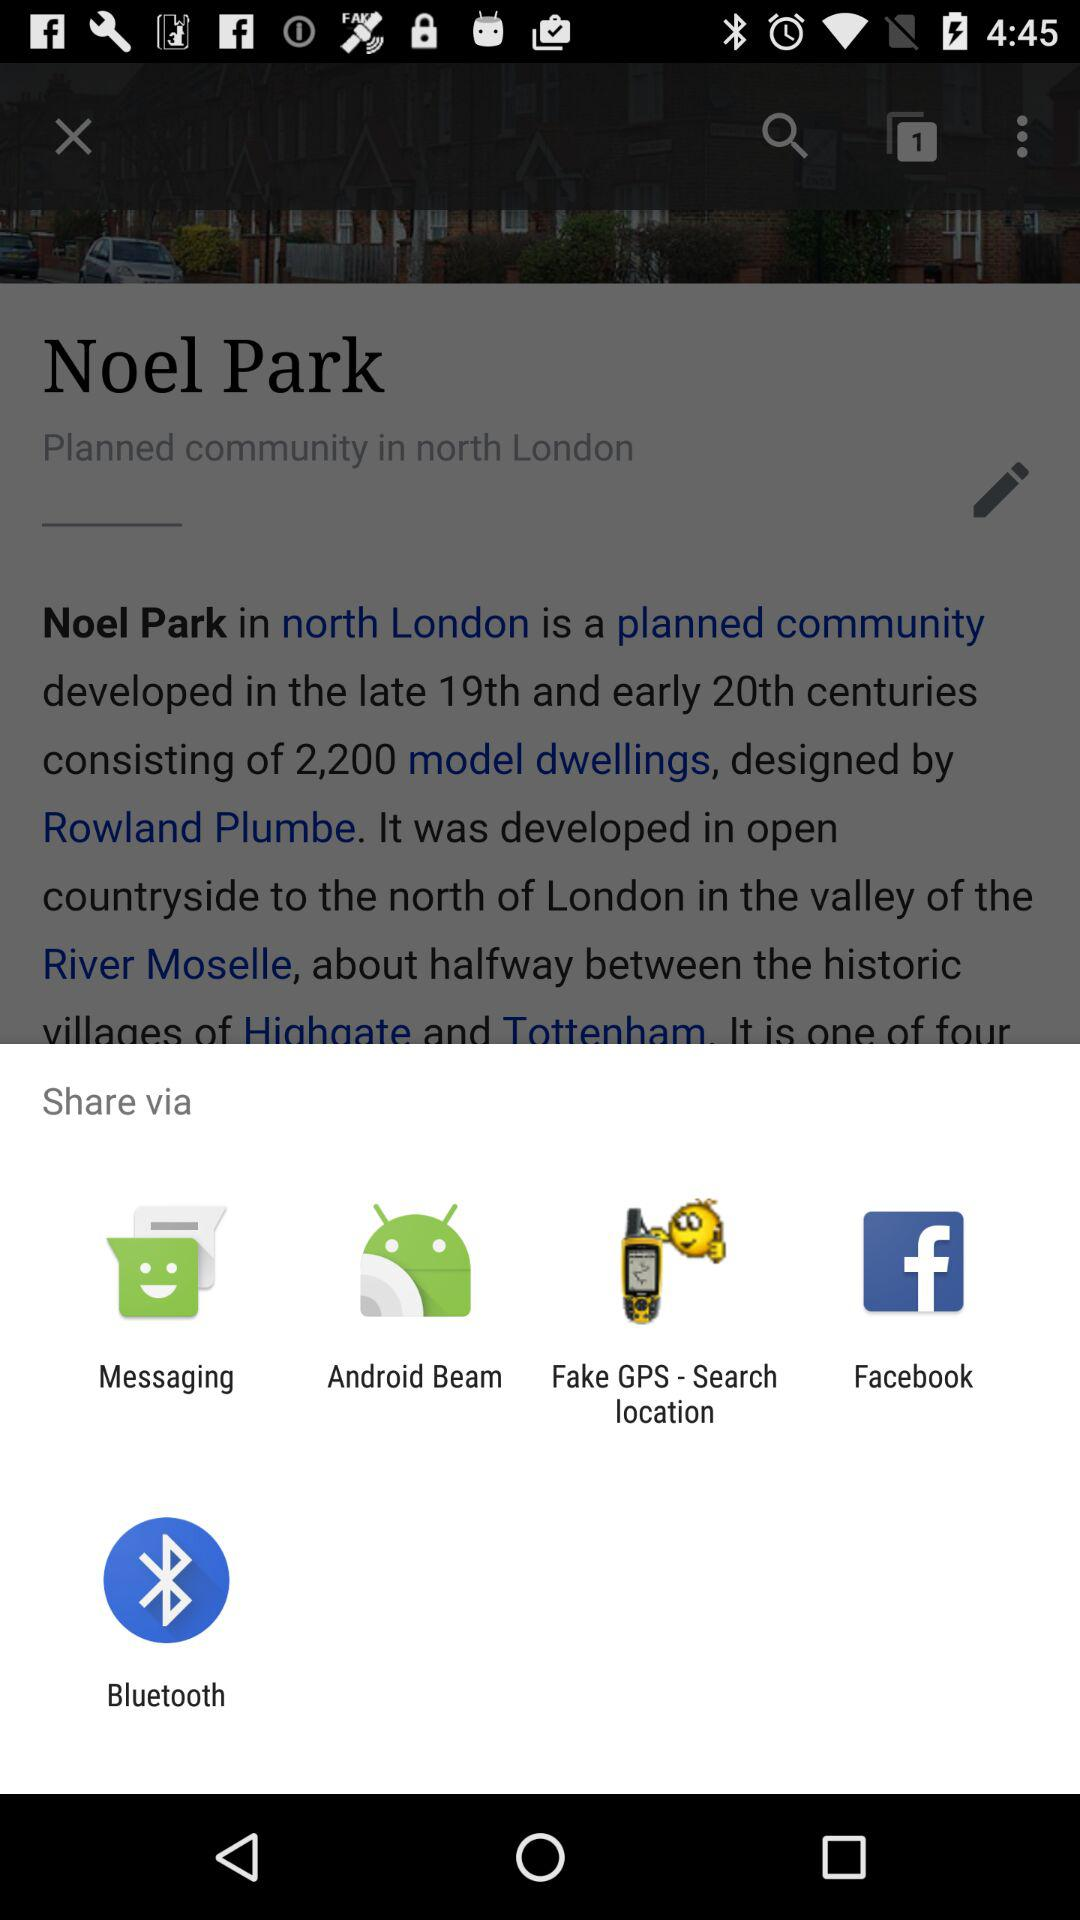In which century was Noel Park developed? The Neol Park was developed in the late 19th and early 20th centuries. 